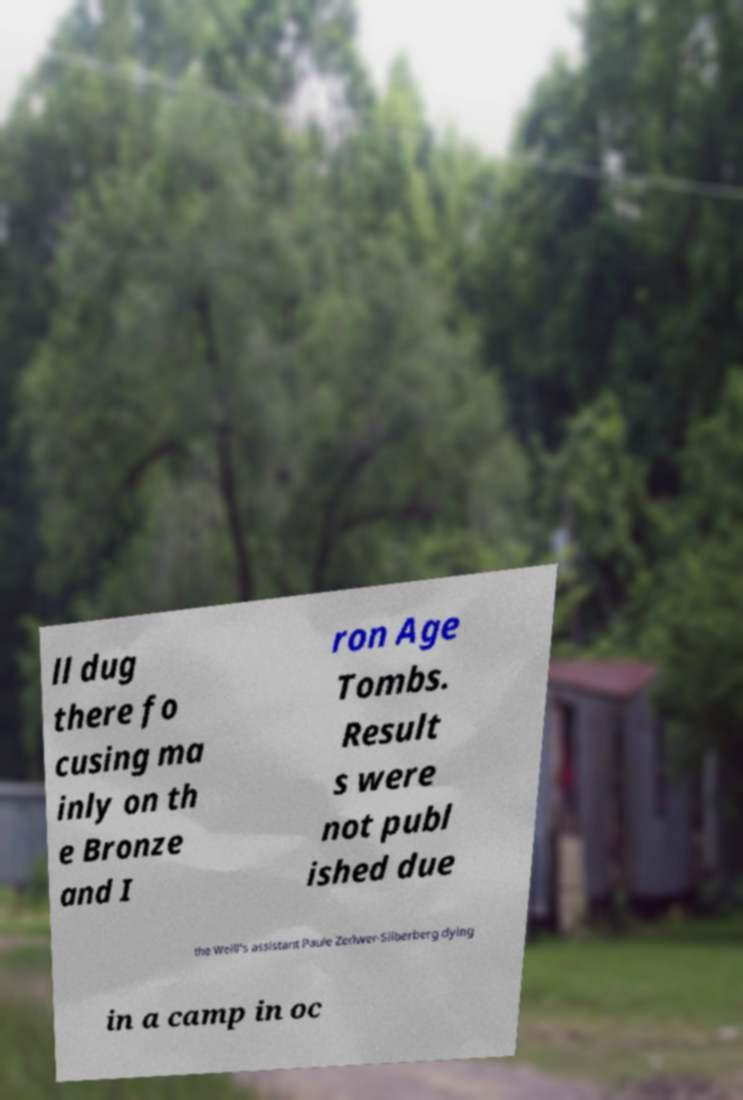Could you extract and type out the text from this image? ll dug there fo cusing ma inly on th e Bronze and I ron Age Tombs. Result s were not publ ished due the Weill's assistant Paule Zerlwer-Silberberg dying in a camp in oc 